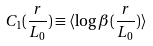<formula> <loc_0><loc_0><loc_500><loc_500>C _ { 1 } ( \frac { r } { L _ { 0 } } ) \equiv \langle \log \beta ( \frac { r } { L _ { 0 } } ) \rangle</formula> 